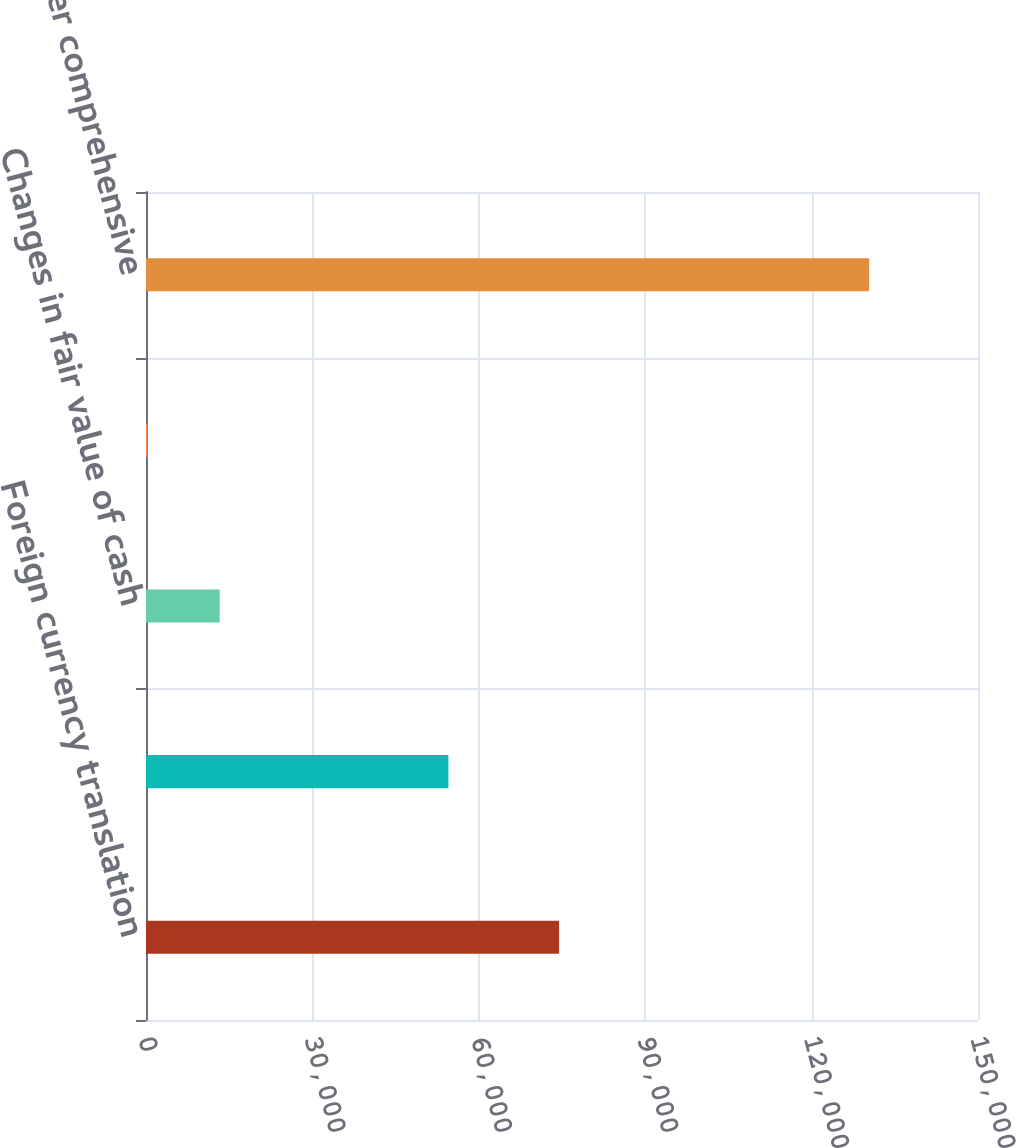<chart> <loc_0><loc_0><loc_500><loc_500><bar_chart><fcel>Foreign currency translation<fcel>Pension and other<fcel>Changes in fair value of cash<fcel>Other<fcel>Total other comprehensive<nl><fcel>74476<fcel>54519<fcel>13280.4<fcel>270<fcel>130374<nl></chart> 